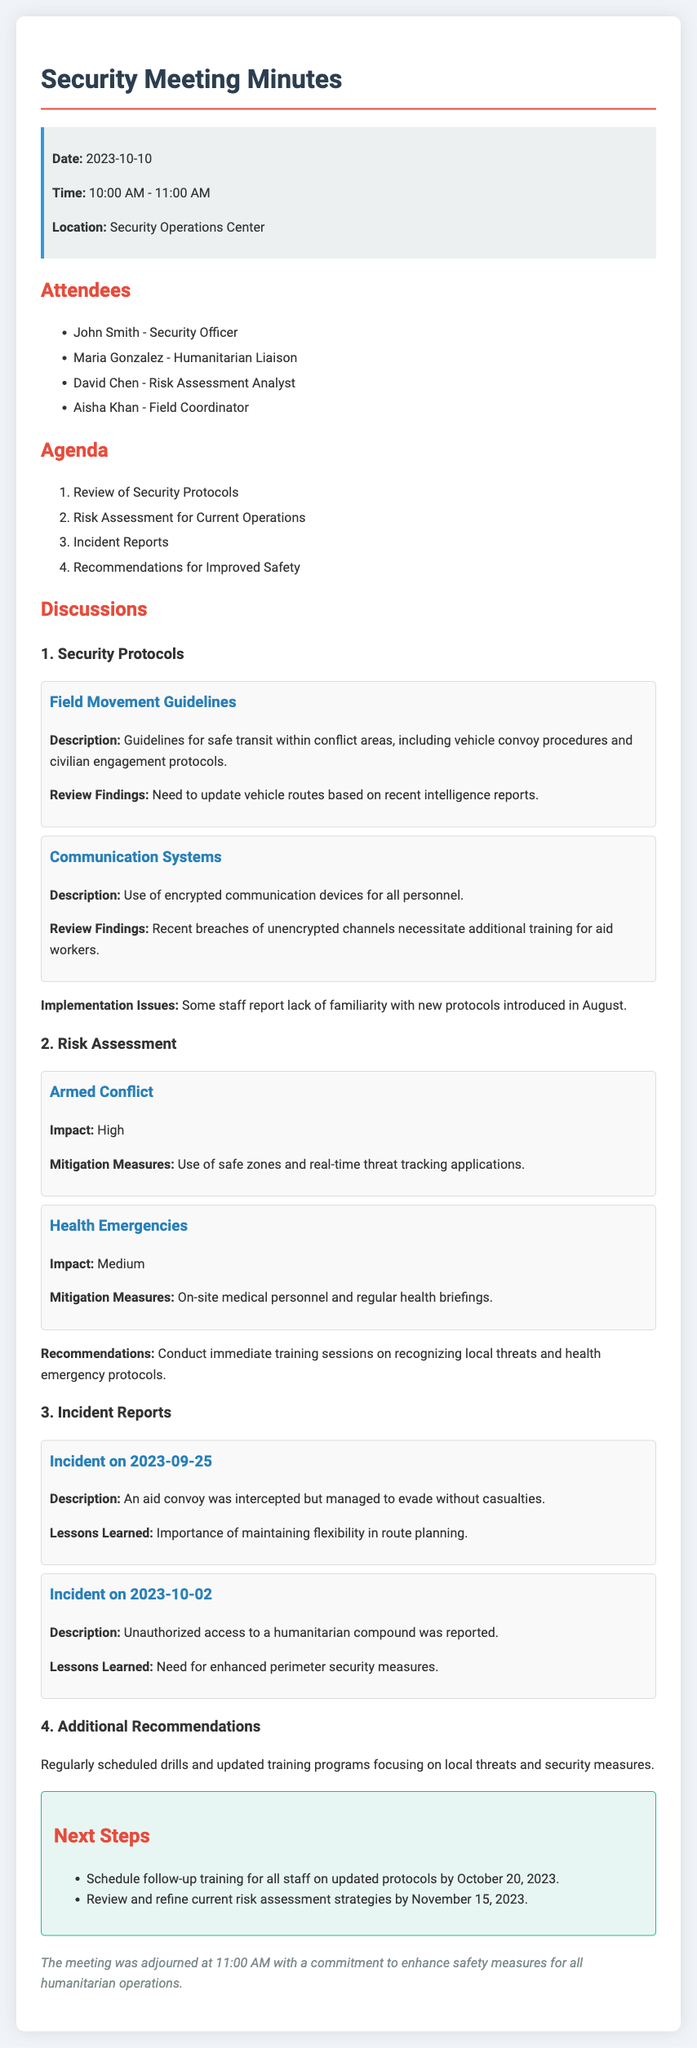what is the date of the meeting? The date of the meeting is explicitly stated in the document.
Answer: 2023-10-10 who is the Humanitarian Liaison? The document lists the attendees, including their titles and roles.
Answer: Maria Gonzalez what are the two main risks discussed? The risks are outlined in detail, including impact and mitigation measures.
Answer: Armed Conflict, Health Emergencies how many incidents were reported? The document specifies the number of incident reports included in the discussions.
Answer: 2 what is one of the recommendations for improved safety? Recommendations for improved safety can be found in the additional recommendations section.
Answer: Regularly scheduled drills who reported unauthorized access to a humanitarian compound? The incident description indicates which event involved unauthorized access.
Answer: Incident on 2023-10-02 when is the follow-up training scheduled? The next steps section includes specific timelines for follow-up actions.
Answer: October 20, 2023 what is one implementation issue noted regarding protocols? The implementation issues mentioned relate to familiarity with new protocols.
Answer: Lack of familiarity with new protocols what should be reviewed and refined by November 15, 2023? Future actions are detailed in the next steps, including what needs to be reviewed.
Answer: Current risk assessment strategies 